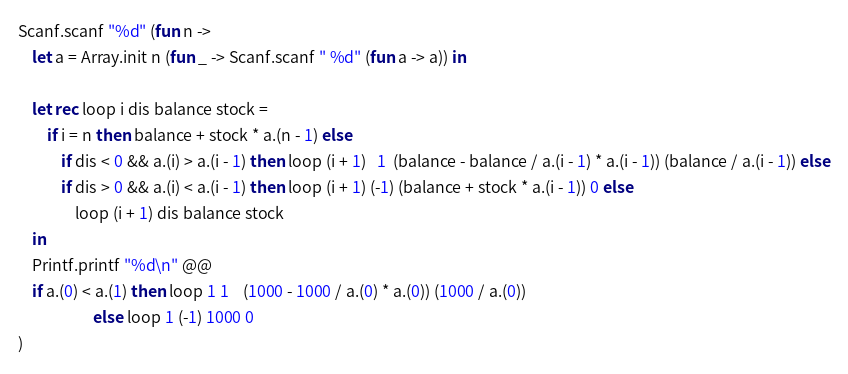<code> <loc_0><loc_0><loc_500><loc_500><_OCaml_>Scanf.scanf "%d" (fun n ->
    let a = Array.init n (fun _ -> Scanf.scanf " %d" (fun a -> a)) in

    let rec loop i dis balance stock =
        if i = n then balance + stock * a.(n - 1) else
            if dis < 0 && a.(i) > a.(i - 1) then loop (i + 1)   1  (balance - balance / a.(i - 1) * a.(i - 1)) (balance / a.(i - 1)) else
            if dis > 0 && a.(i) < a.(i - 1) then loop (i + 1) (-1) (balance + stock * a.(i - 1)) 0 else
                loop (i + 1) dis balance stock
    in
    Printf.printf "%d\n" @@ 
    if a.(0) < a.(1) then loop 1 1    (1000 - 1000 / a.(0) * a.(0)) (1000 / a.(0))
                     else loop 1 (-1) 1000 0
)
</code> 